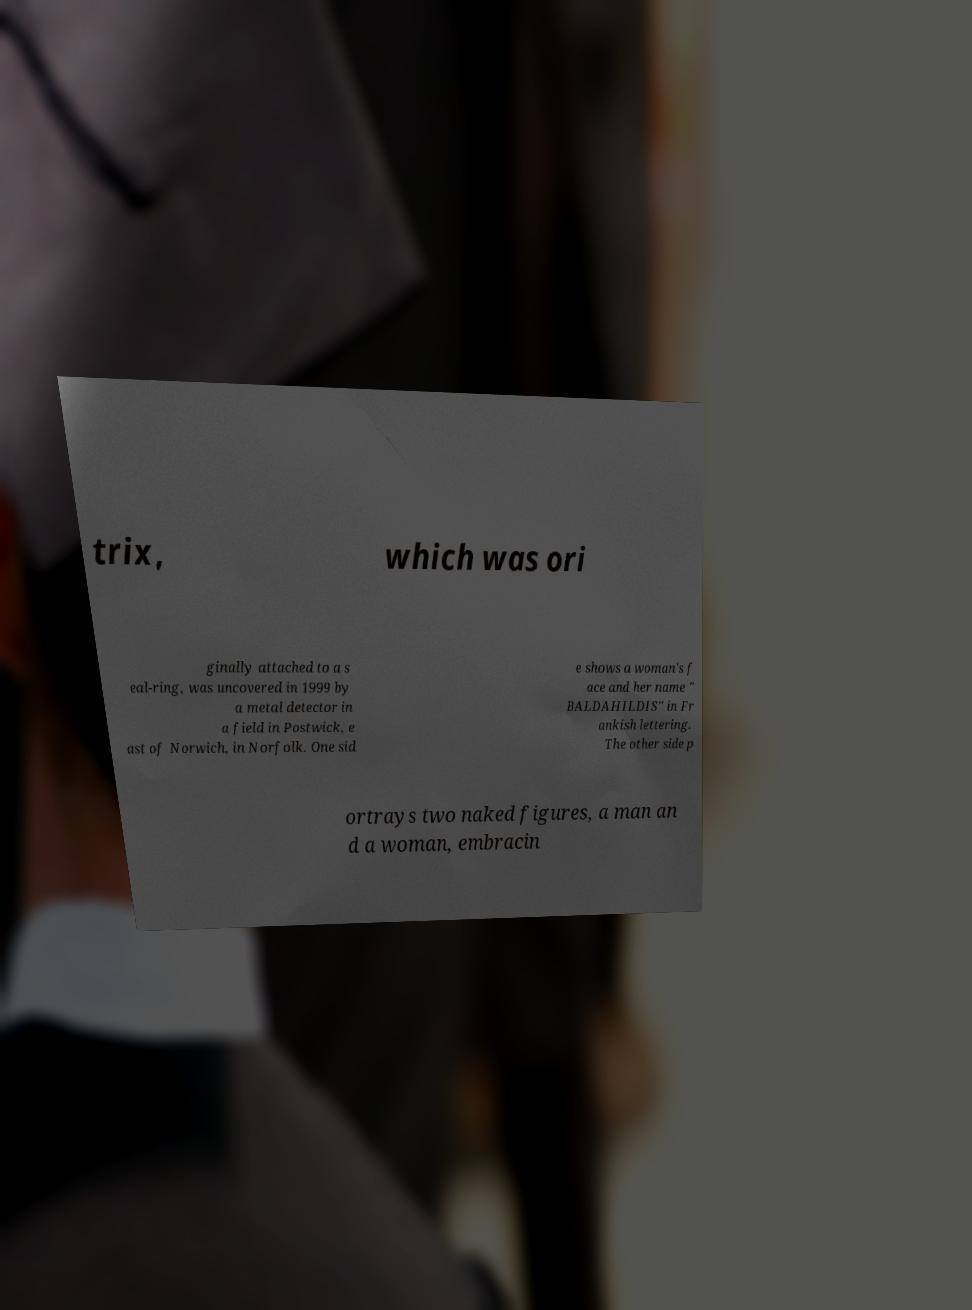What messages or text are displayed in this image? I need them in a readable, typed format. trix, which was ori ginally attached to a s eal-ring, was uncovered in 1999 by a metal detector in a field in Postwick, e ast of Norwich, in Norfolk. One sid e shows a woman's f ace and her name " BALDAHILDIS" in Fr ankish lettering. The other side p ortrays two naked figures, a man an d a woman, embracin 